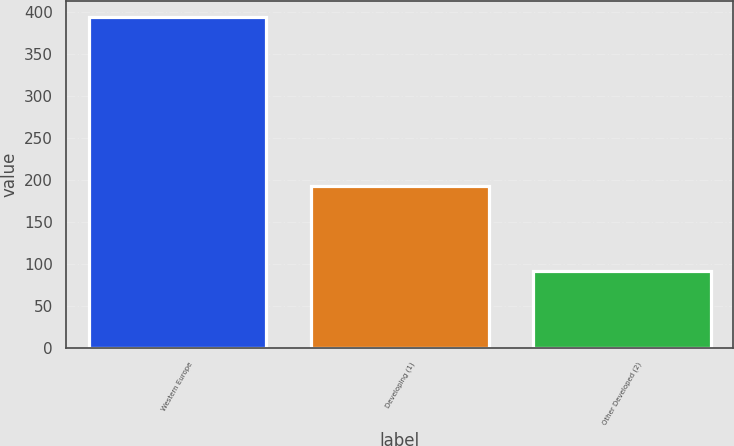Convert chart. <chart><loc_0><loc_0><loc_500><loc_500><bar_chart><fcel>Western Europe<fcel>Developing (1)<fcel>Other Developed (2)<nl><fcel>393.9<fcel>193.3<fcel>91.7<nl></chart> 